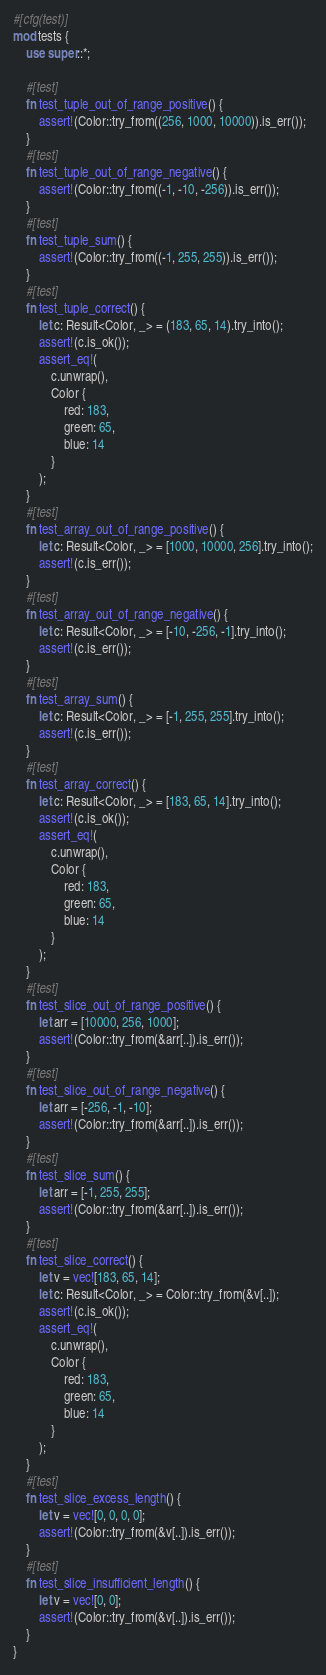Convert code to text. <code><loc_0><loc_0><loc_500><loc_500><_Rust_>#[cfg(test)]
mod tests {
    use super::*;

    #[test]
    fn test_tuple_out_of_range_positive() {
        assert!(Color::try_from((256, 1000, 10000)).is_err());
    }
    #[test]
    fn test_tuple_out_of_range_negative() {
        assert!(Color::try_from((-1, -10, -256)).is_err());
    }
    #[test]
    fn test_tuple_sum() {
        assert!(Color::try_from((-1, 255, 255)).is_err());
    }
    #[test]
    fn test_tuple_correct() {
        let c: Result<Color, _> = (183, 65, 14).try_into();
        assert!(c.is_ok());
        assert_eq!(
            c.unwrap(),
            Color {
                red: 183,
                green: 65,
                blue: 14
            }
        );
    }
    #[test]
    fn test_array_out_of_range_positive() {
        let c: Result<Color, _> = [1000, 10000, 256].try_into();
        assert!(c.is_err());
    }
    #[test]
    fn test_array_out_of_range_negative() {
        let c: Result<Color, _> = [-10, -256, -1].try_into();
        assert!(c.is_err());
    }
    #[test]
    fn test_array_sum() {
        let c: Result<Color, _> = [-1, 255, 255].try_into();
        assert!(c.is_err());
    }
    #[test]
    fn test_array_correct() {
        let c: Result<Color, _> = [183, 65, 14].try_into();
        assert!(c.is_ok());
        assert_eq!(
            c.unwrap(),
            Color {
                red: 183,
                green: 65,
                blue: 14
            }
        );
    }
    #[test]
    fn test_slice_out_of_range_positive() {
        let arr = [10000, 256, 1000];
        assert!(Color::try_from(&arr[..]).is_err());
    }
    #[test]
    fn test_slice_out_of_range_negative() {
        let arr = [-256, -1, -10];
        assert!(Color::try_from(&arr[..]).is_err());
    }
    #[test]
    fn test_slice_sum() {
        let arr = [-1, 255, 255];
        assert!(Color::try_from(&arr[..]).is_err());
    }
    #[test]
    fn test_slice_correct() {
        let v = vec![183, 65, 14];
        let c: Result<Color, _> = Color::try_from(&v[..]);
        assert!(c.is_ok());
        assert_eq!(
            c.unwrap(),
            Color {
                red: 183,
                green: 65,
                blue: 14
            }
        );
    }
    #[test]
    fn test_slice_excess_length() {
        let v = vec![0, 0, 0, 0];
        assert!(Color::try_from(&v[..]).is_err());
    }
    #[test]
    fn test_slice_insufficient_length() {
        let v = vec![0, 0];
        assert!(Color::try_from(&v[..]).is_err());
    }
}
</code> 